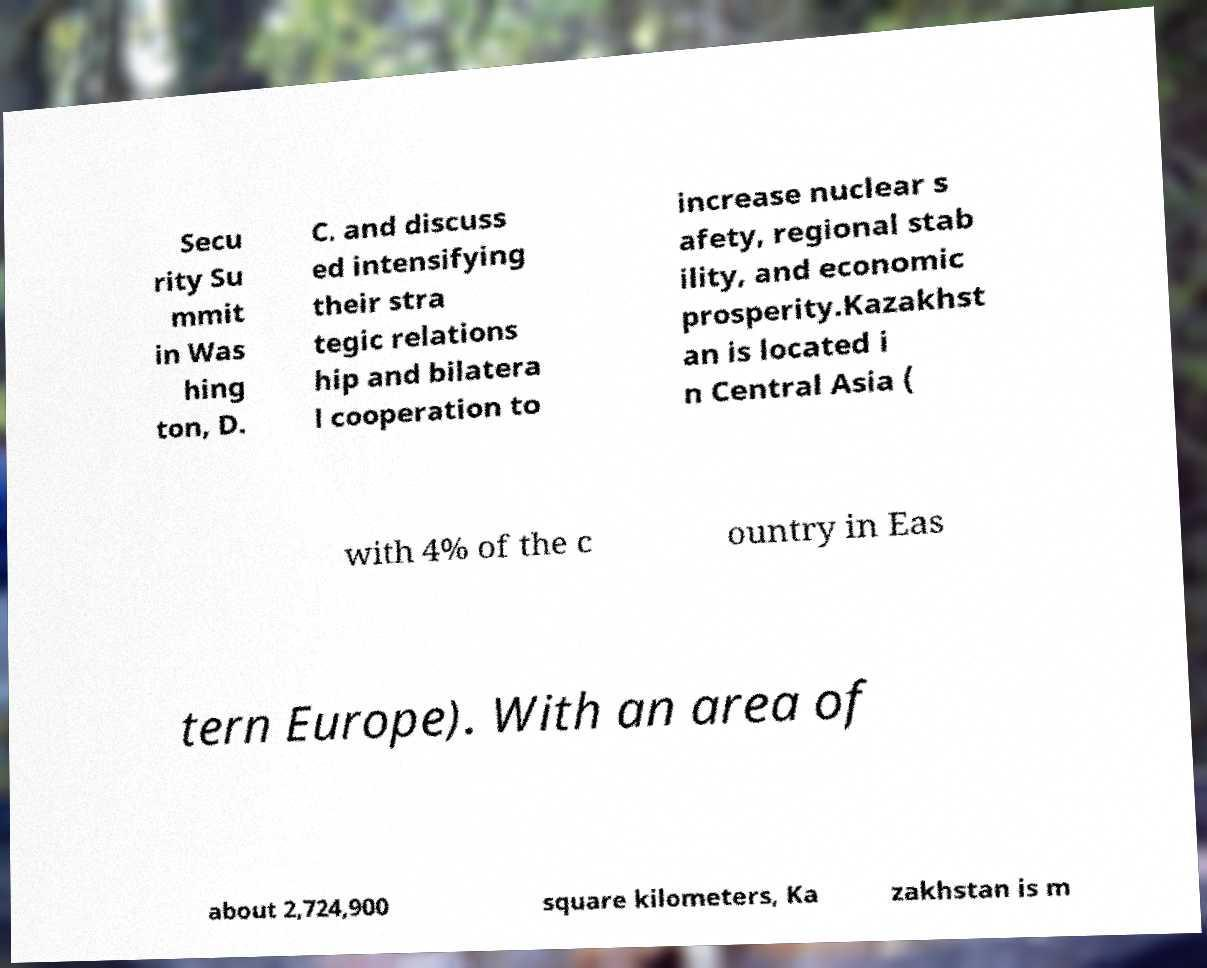Could you extract and type out the text from this image? Secu rity Su mmit in Was hing ton, D. C. and discuss ed intensifying their stra tegic relations hip and bilatera l cooperation to increase nuclear s afety, regional stab ility, and economic prosperity.Kazakhst an is located i n Central Asia ( with 4% of the c ountry in Eas tern Europe). With an area of about 2,724,900 square kilometers, Ka zakhstan is m 